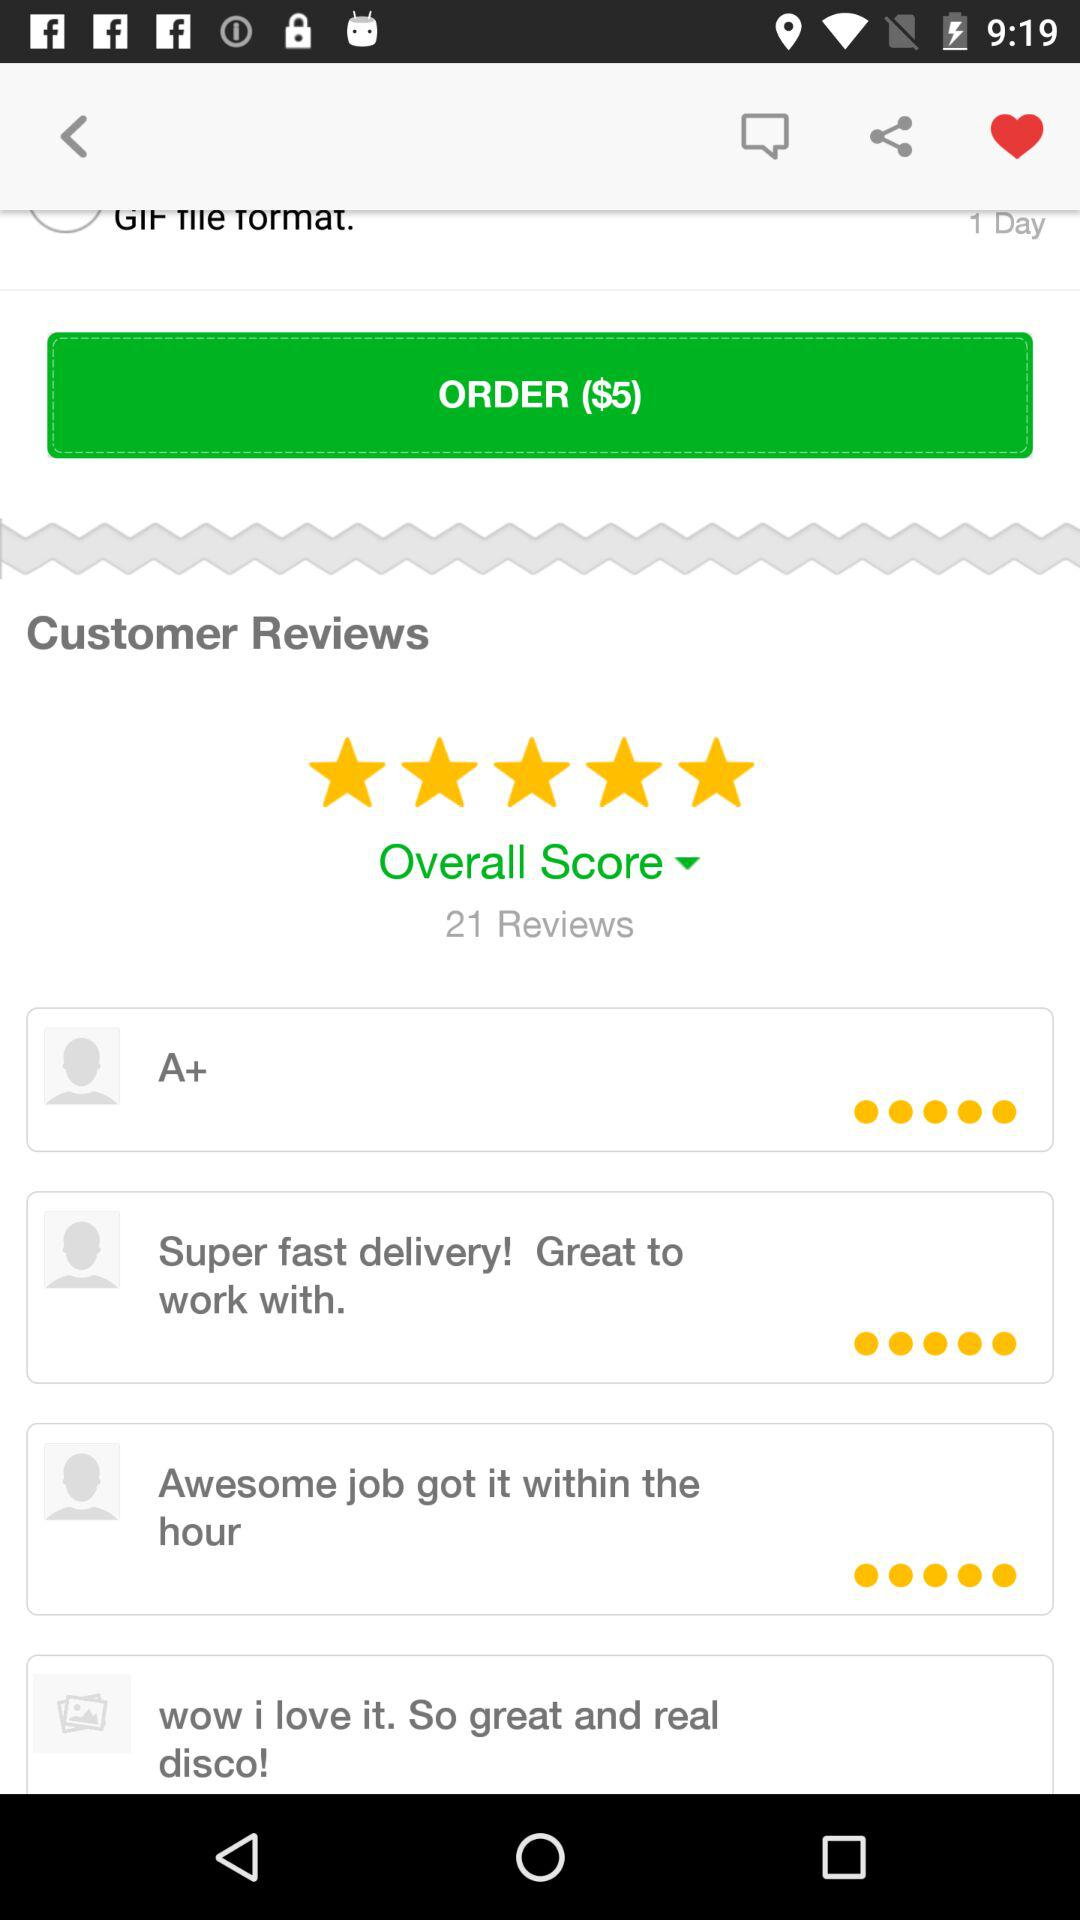How many total customer reviews are there? There are a total of 21 reviews. 